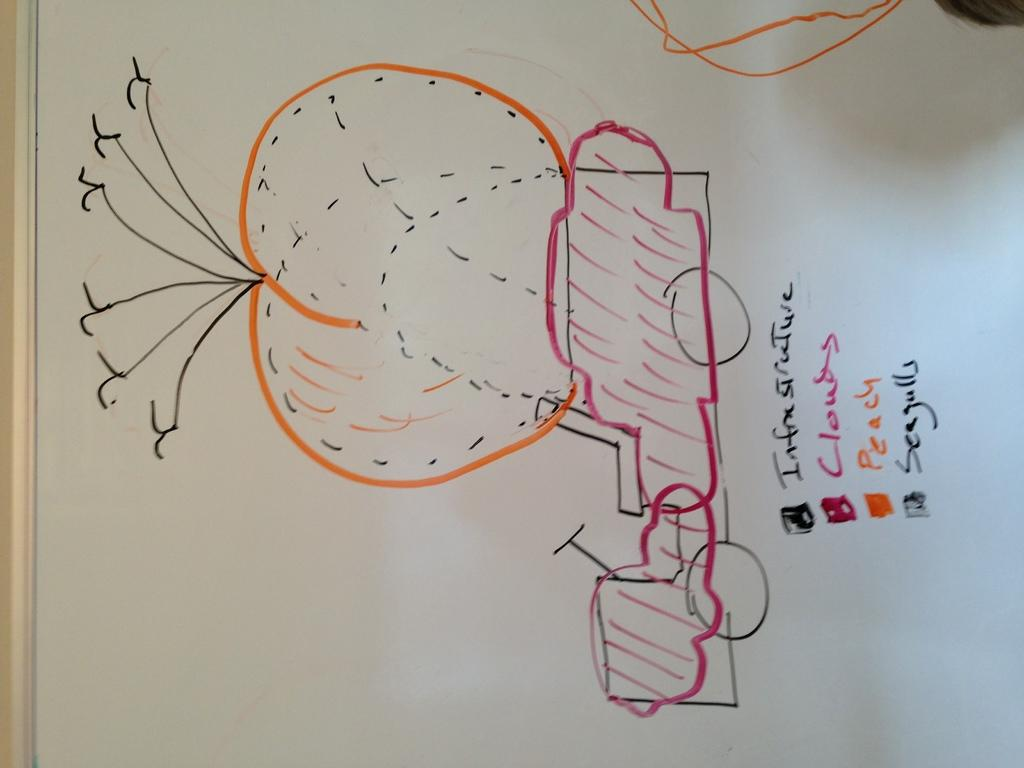<image>
Relay a brief, clear account of the picture shown. A drawn diagram showing infrastructure, cloud, peach and seagulls. 